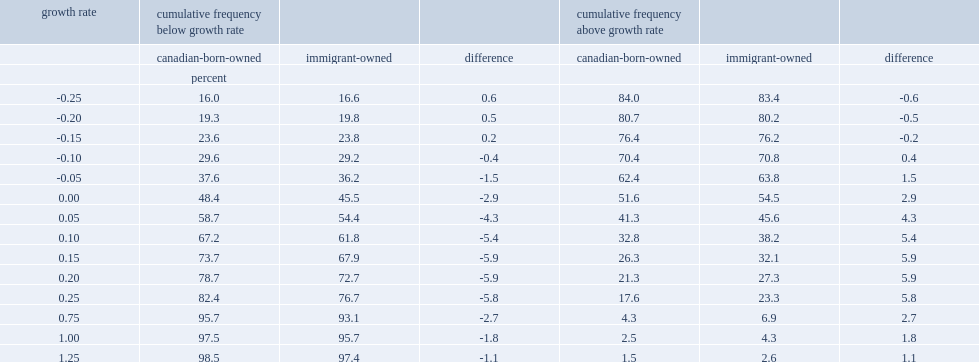Among job creators (firms with positive employment growth), what was the percent of immigrant-owned firms were considered high-growth firms? 27.3. Among job creators (firms with positive employment growth), what was the percent of firms with canadian-born owners? 21.3. Among job creators (firms with positive employment growth),what was the difference between immigrant-owned firms and firms with canadian-born owners? 5.9. 